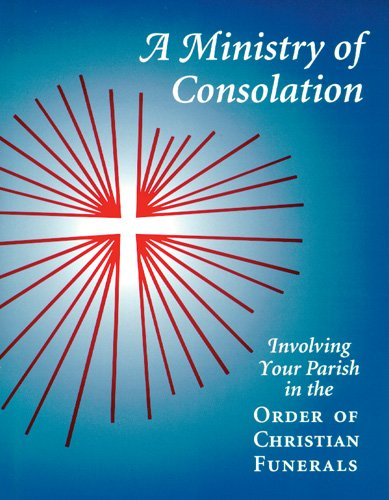Is this book related to Teen & Young Adult? No, this book is not targeted towards the Teen & Young Adult demographic; rather, it's designed for parish members and leaders. 